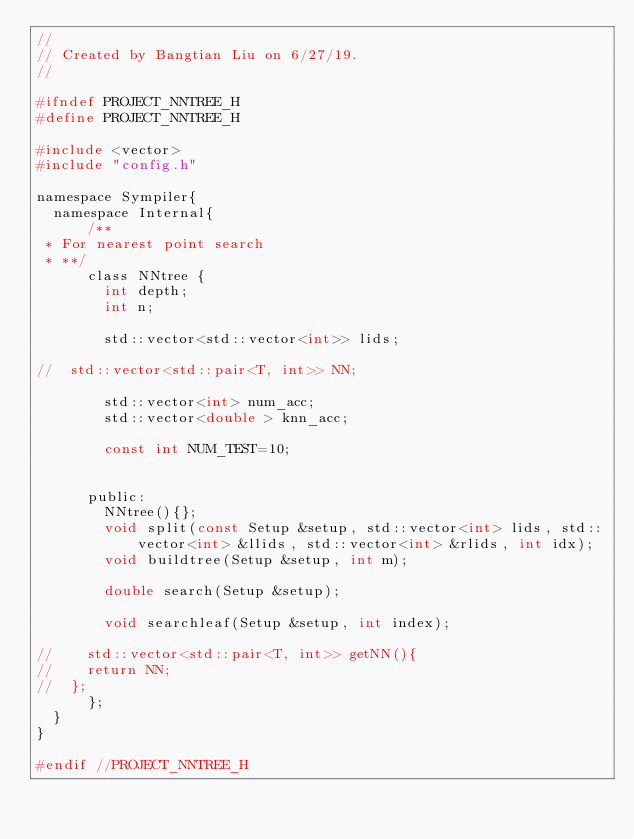Convert code to text. <code><loc_0><loc_0><loc_500><loc_500><_C_>//
// Created by Bangtian Liu on 6/27/19.
//

#ifndef PROJECT_NNTREE_H
#define PROJECT_NNTREE_H

#include <vector>
#include "config.h"

namespace Sympiler{
	namespace Internal{
			/**
 * For nearest point search
 * **/
			class NNtree {
				int depth;
				int n;

				std::vector<std::vector<int>> lids;

//	std::vector<std::pair<T, int>> NN;

				std::vector<int> num_acc;
				std::vector<double > knn_acc;

				const int NUM_TEST=10;


			public:
				NNtree(){};
				void split(const Setup &setup, std::vector<int> lids, std::vector<int> &llids, std::vector<int> &rlids, int idx);
				void buildtree(Setup &setup, int m);

				double search(Setup &setup);

				void searchleaf(Setup &setup, int index);

//    std::vector<std::pair<T, int>> getNN(){
//		return NN;
//	};
			};
	}
}

#endif //PROJECT_NNTREE_H
</code> 